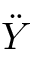<formula> <loc_0><loc_0><loc_500><loc_500>\ddot { Y }</formula> 